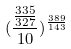<formula> <loc_0><loc_0><loc_500><loc_500>( \frac { \frac { 3 3 5 } { 3 2 7 } } { 1 0 } ) ^ { \frac { 3 8 9 } { 1 4 3 } }</formula> 